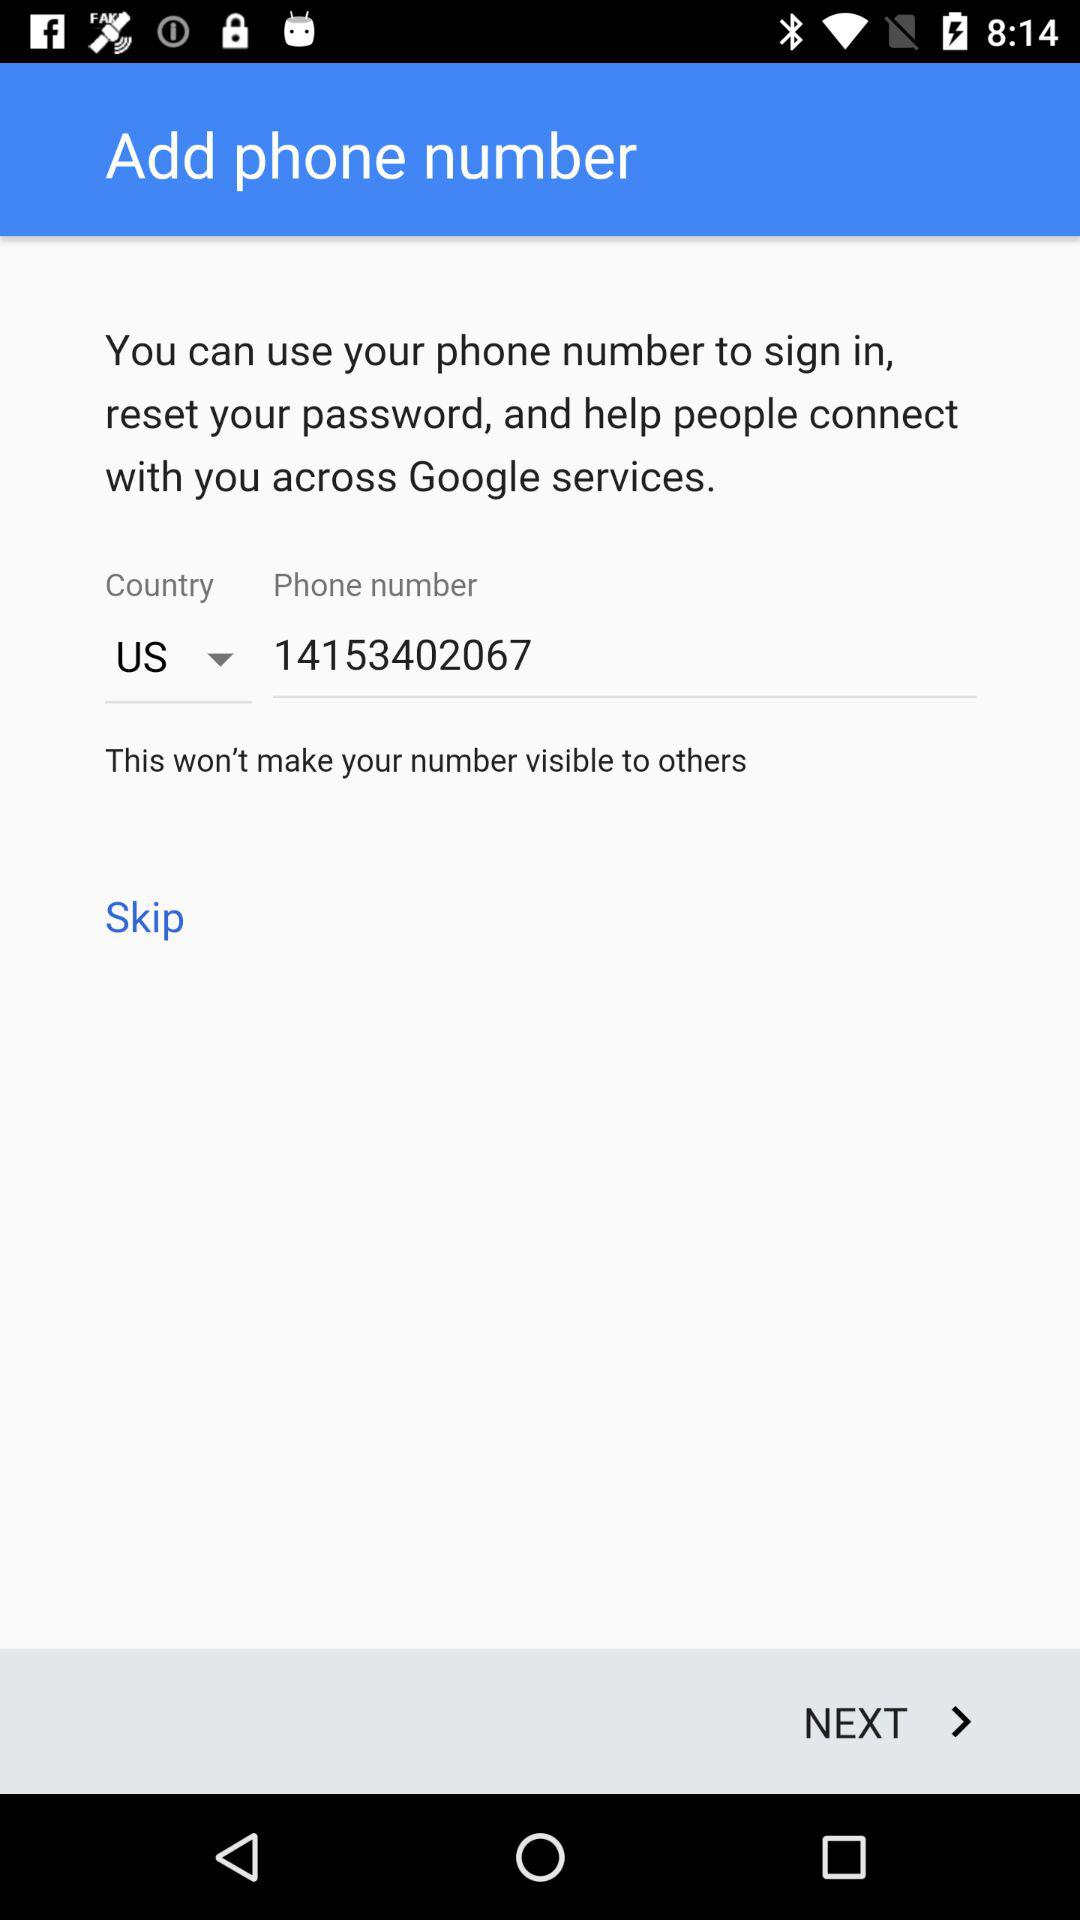How many fields are there in the phone number input form?
Answer the question using a single word or phrase. 2 